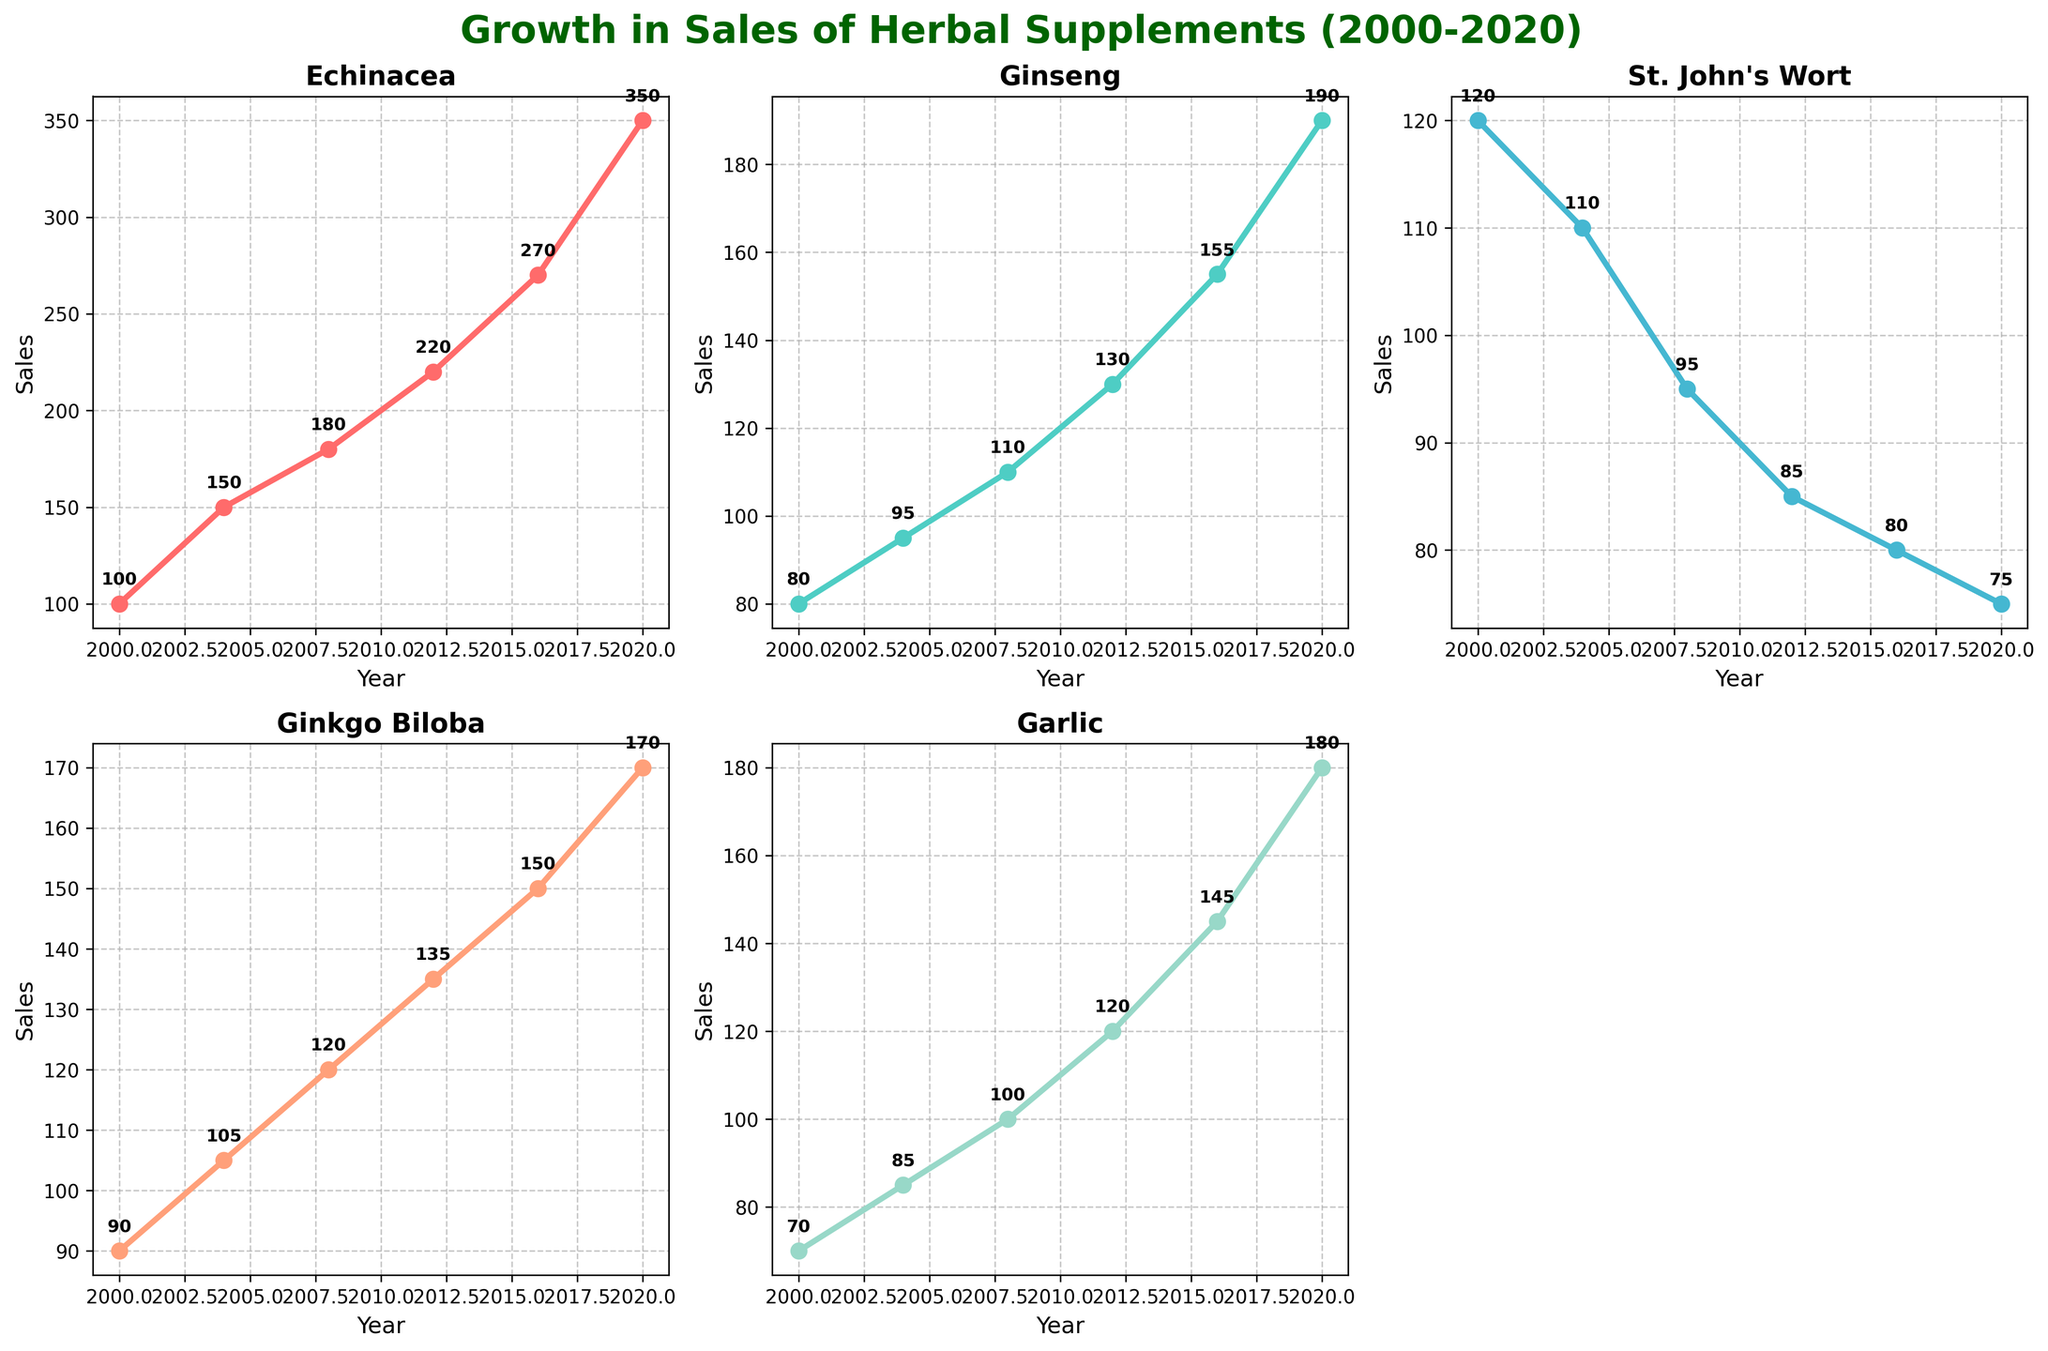What is the title of the plot? The title of the plot is typically found at the top center of the figure and gives an overview of what the figure is about. Here, the title reads "Growth in Sales of Herbal Supplements (2000-2020)" indicating the time span and subject of the data.
Answer: Growth in Sales of Herbal Supplements (2000-2020) What years are represented on the x-axis? The x-axis shows the range of years for which data is displayed. The values on the x-axis in the plot are marked as 2000, 2004, 2008, 2012, 2016, and 2020.
Answer: 2000, 2004, 2008, 2012, 2016, and 2020 Which herbal supplement had the highest sales in 2020? To determine the herbal supplement with the highest sales in 2020, we need to look at the data points above the year 2020 on the x-axis for each subplot. By comparing the heights of the final data points, it is clear that Echinacea had the highest value at 350.
Answer: Echinacea How did the sales of Ginseng change from 2000 to 2020? To understand the change in sales of Ginseng, look at the trend line for Ginseng from the year 2000 to 2020. The sales increased from 80 in 2000 to 190 in 2020.
Answer: Increased What is the average sales value of Garlic over the years? Calculate the average sales value of Garlic by summing the sales values for each year and dividing by the number of years (70 + 85 + 100 + 120 + 145 + 180) / 6. The sum is 700 and the average is 700/6 ≈ 116.67.
Answer: 116.67 Between which years did St. John's Wort see the largest decrease in sales? By analyzing the trend line for St. John's Wort, we can compare the differences in sales between consecutive years. The largest decrease happens between 2000 (120) and 2004 (110), which amounts to a drop of 10.
Answer: 2000 and 2004 Which two herbal supplements had sales values close to each other in 2016? In 2016, by examining the values of each subplot, we find that Ginkgo Biloba (150) and Ginseng (155) had sales values close to one another.
Answer: Ginkgo Biloba and Ginseng How many subplots are there in the figure? The figure is divided into subplots, each representing a different herbal supplement. By counting these distinct sections, we see there are 5 subplots as one of the spaces is empty.
Answer: 5 Which herbal supplement showed the most consistent growth over the years? To determine the most consistent growth, observe the trend lines of each herbal supplement. Echinacea shows a consistent upward trend without dips, indicating steady growth.
Answer: Echinacea 